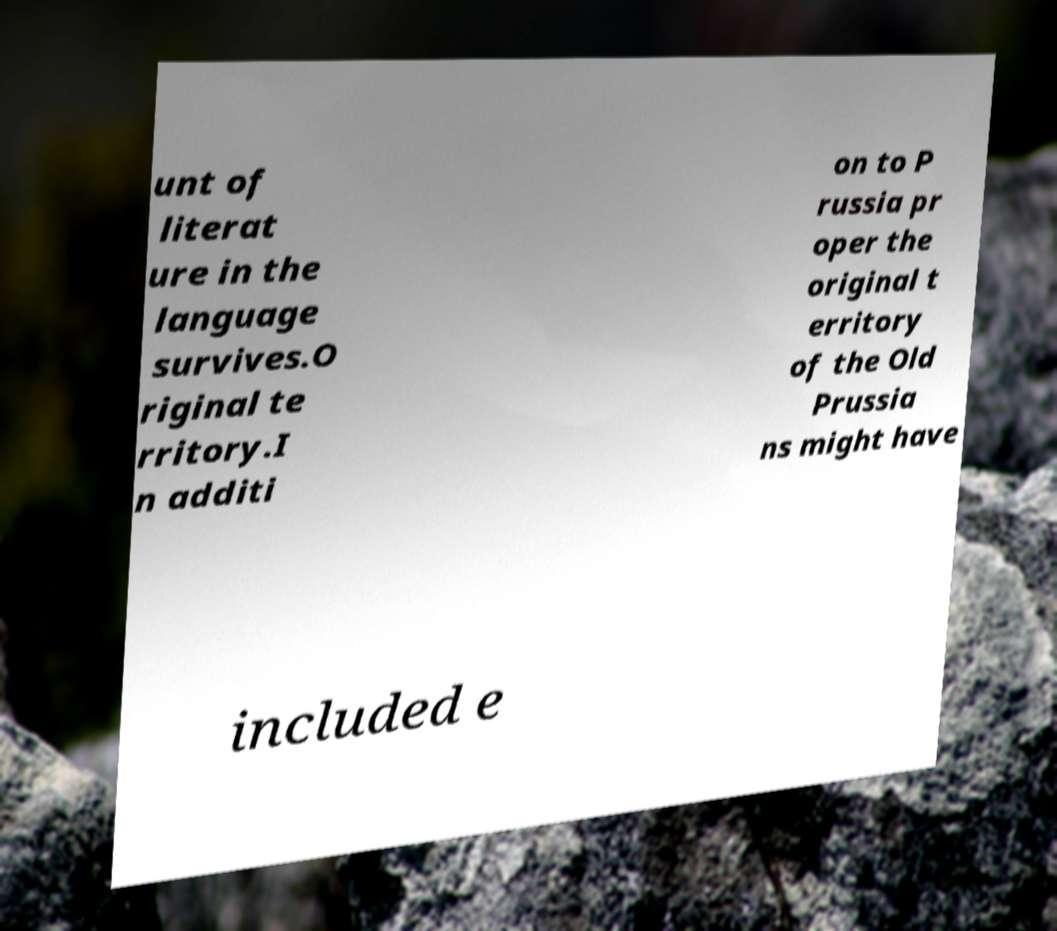Can you read and provide the text displayed in the image?This photo seems to have some interesting text. Can you extract and type it out for me? unt of literat ure in the language survives.O riginal te rritory.I n additi on to P russia pr oper the original t erritory of the Old Prussia ns might have included e 